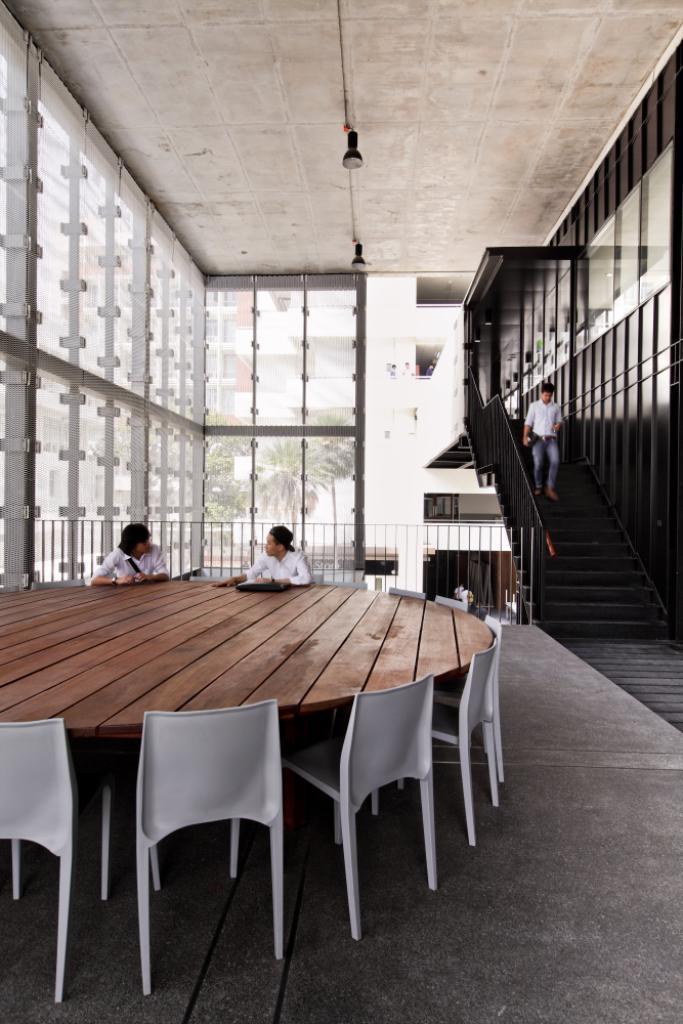How would you summarize this image in a sentence or two? The picture is taken in a building. In the foreground of the picture there are chairs, table, people and windows. On the left there is a person walking down the staircase. In the center of the background there is railing, glass windows, outside the windows there are trees and a building. 